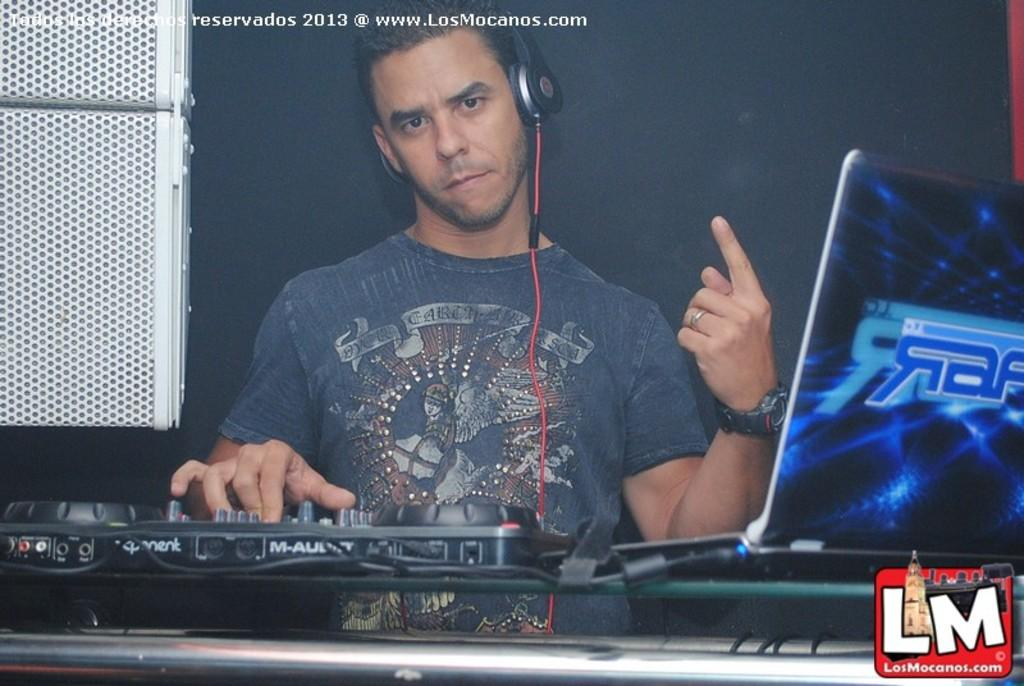Who or what is present in the image? There is a person in the image. What electronic device can be seen in the image? There is a laptop in the image. What accessory is visible in the image? There are headphones in the image. Can you describe any other objects in the image? There are some objects in the image, but their specific details are not mentioned in the facts. What text is present in the image? There is text in the top left corner of the image. What symbol or graphic is present in the image? There is a logo in the bottom right corner of the image. What type of cherry is being used as a decoration on the laptop in the image? There is no cherry present in the image, as it only features a person, a laptop, headphones, objects, text, and a logo. 